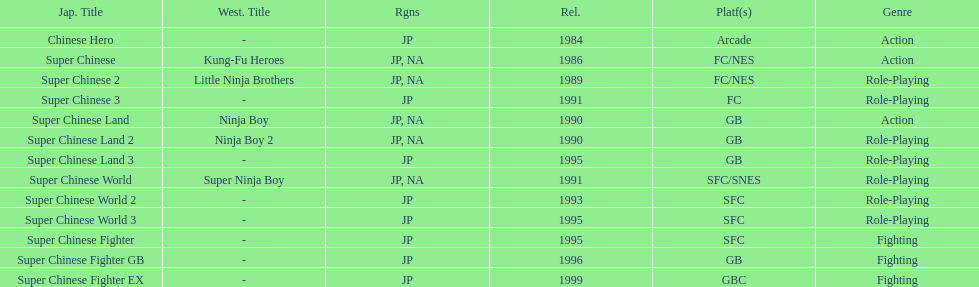Which platforms had the most titles released? GB. 